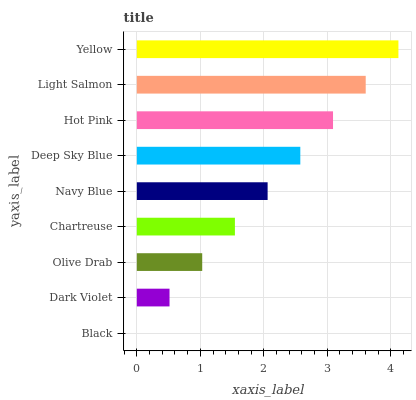Is Black the minimum?
Answer yes or no. Yes. Is Yellow the maximum?
Answer yes or no. Yes. Is Dark Violet the minimum?
Answer yes or no. No. Is Dark Violet the maximum?
Answer yes or no. No. Is Dark Violet greater than Black?
Answer yes or no. Yes. Is Black less than Dark Violet?
Answer yes or no. Yes. Is Black greater than Dark Violet?
Answer yes or no. No. Is Dark Violet less than Black?
Answer yes or no. No. Is Navy Blue the high median?
Answer yes or no. Yes. Is Navy Blue the low median?
Answer yes or no. Yes. Is Yellow the high median?
Answer yes or no. No. Is Hot Pink the low median?
Answer yes or no. No. 